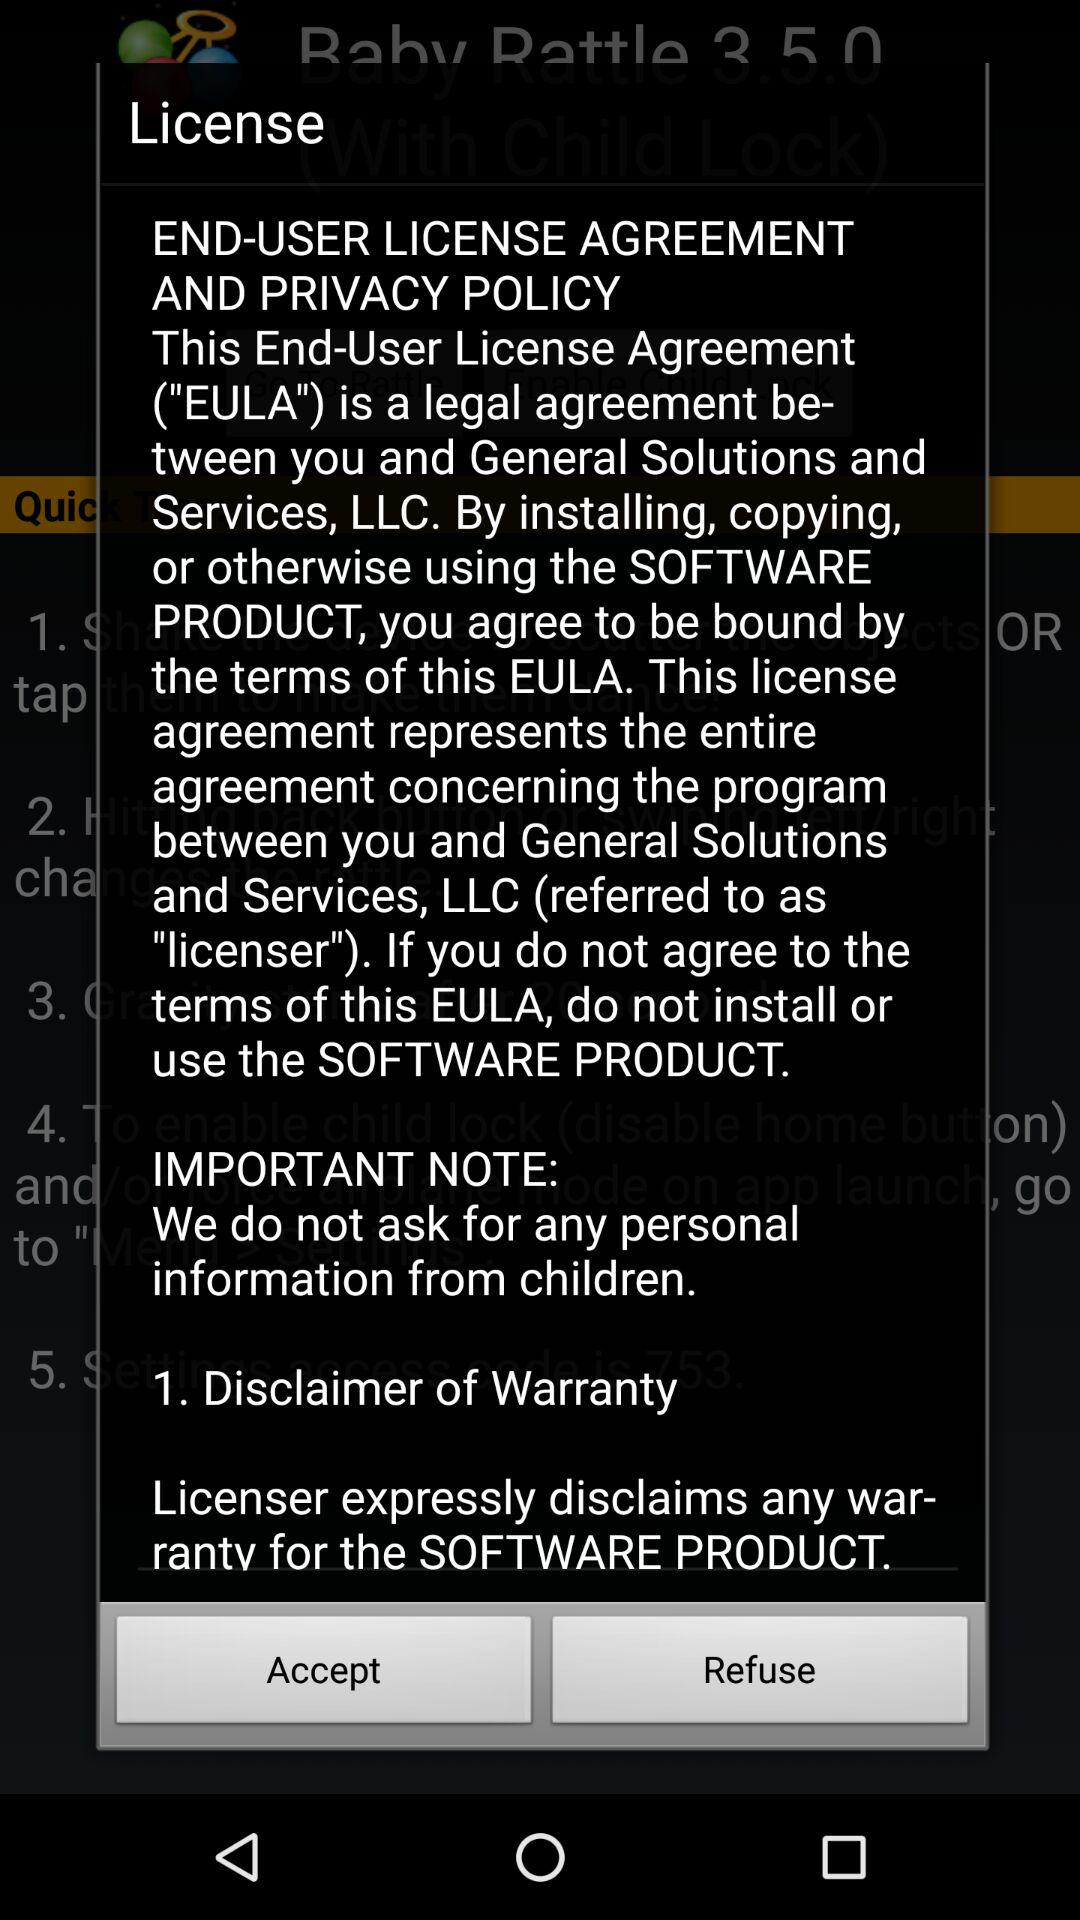Has the user agreed to the license agreement and privacy policy?
When the provided information is insufficient, respond with <no answer>. <no answer> 